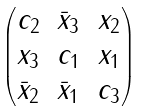<formula> <loc_0><loc_0><loc_500><loc_500>\begin{pmatrix} c _ { 2 } & \bar { x } _ { 3 } & x _ { 2 } \\ x _ { 3 } & c _ { 1 } & x _ { 1 } \\ \bar { x } _ { 2 } & \bar { x } _ { 1 } & c _ { 3 } \end{pmatrix}</formula> 